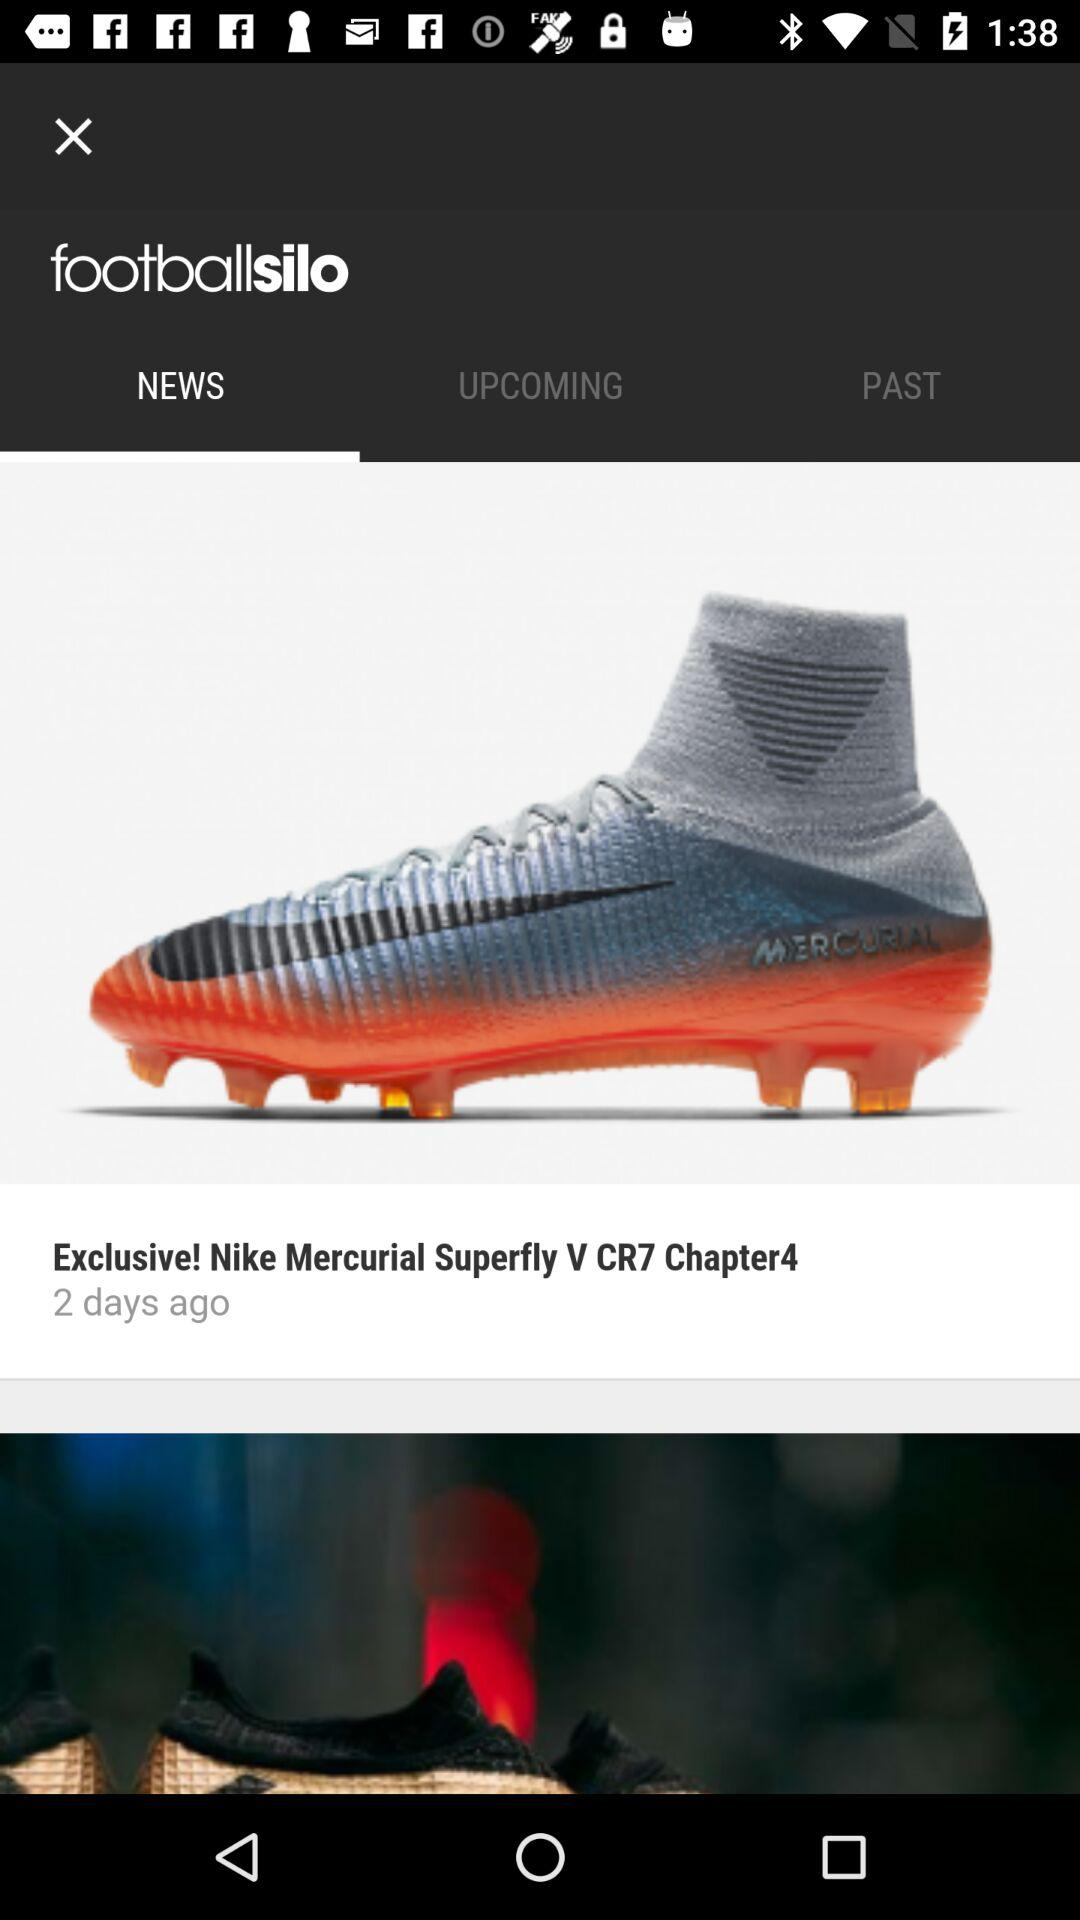Which tab has been selected? The selected tab is "NEWS". 